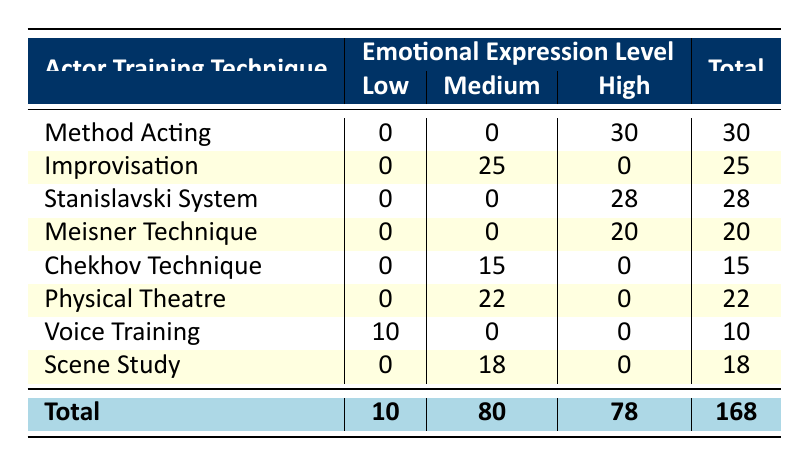What is the total number of participants who used Method Acting? The table shows that the total number of participants for Method Acting is listed as 30.
Answer: 30 How many techniques have a High level of Emotional Expression? Upon reviewing the table, it shows that there are four techniques with a High level of Emotional Expression: Method Acting, Stanislavski System, Meisner Technique, and Voice Training. Therefore, the total count is 4.
Answer: 4 What is the difference in the number of participants between Voice Training and Physical Theatre? Voice Training has 10 participants while Physical Theatre has 22 participants. To find the difference, subtract the participants in Voice Training from those in Physical Theatre: 22 - 10 = 12.
Answer: 12 Is there any technique that falls under the Low emotional expression level? Looking through the table, it is confirmed that Voice Training is the only technique with a Low emotional expression level, which includes 10 participants.
Answer: Yes What is the average number of participants across all techniques with a Medium level of Emotional Expression? The techniques with Medium expression levels and their participants are: Improvisation (25), Chekhov Technique (15), Physical Theatre (22), and Scene Study (18). To find the average: (25 + 15 + 22 + 18) / 4 = 80 / 4 = 20.
Answer: 20 Which technique has the highest number of participants with a High Emotional Expression? Method Acting has the highest number of participants with a High Emotional Expression level listed as 30, which is greater than the other techniques (Stanislavski System: 28, Meisner Technique: 20).
Answer: Method Acting What percentage of the total participants used the Stanislavski System? The total number of participants is 168. The Stanislavski System has 28 participants. To get the percentage, divide 28 by 168 and multiply by 100: (28 / 168) * 100 = 16.67%.
Answer: 16.67% How many total participants are recorded for techniques that fall under a Medium level of emotional expression? The techniques with Medium emotional expression and their participants are: Improvisation (25), Chekhov Technique (15), Physical Theatre (22), and Scene Study (18). Adding these gives us: 25 + 15 + 22 + 18 = 80.
Answer: 80 Is the total number of participants using Voice Training higher than that of Chekhov Technique? Voice Training has 10 participants, while Chekhov Technique has 15. Since 10 is not greater than 15, the statement is false.
Answer: No 